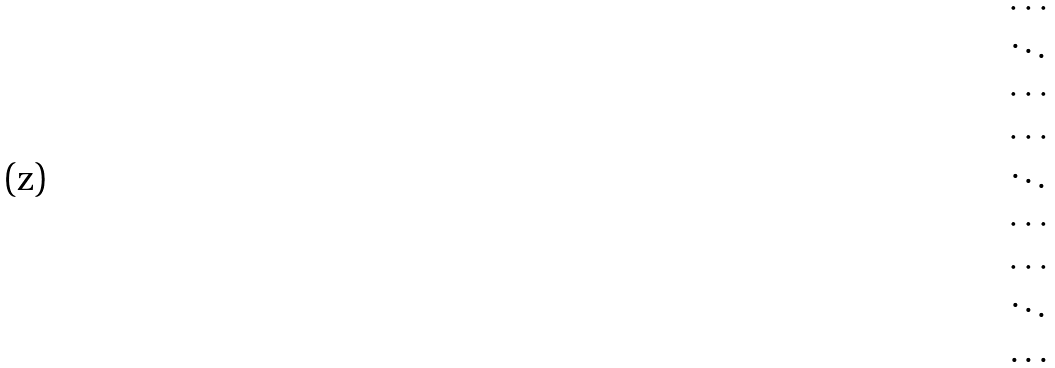Convert formula to latex. <formula><loc_0><loc_0><loc_500><loc_500>\begin{matrix} \cdots \\ \ddots \\ \cdots \\ \cdots \\ \ddots \\ \cdots \\ \cdots \\ \ddots \\ \dots \end{matrix}</formula> 